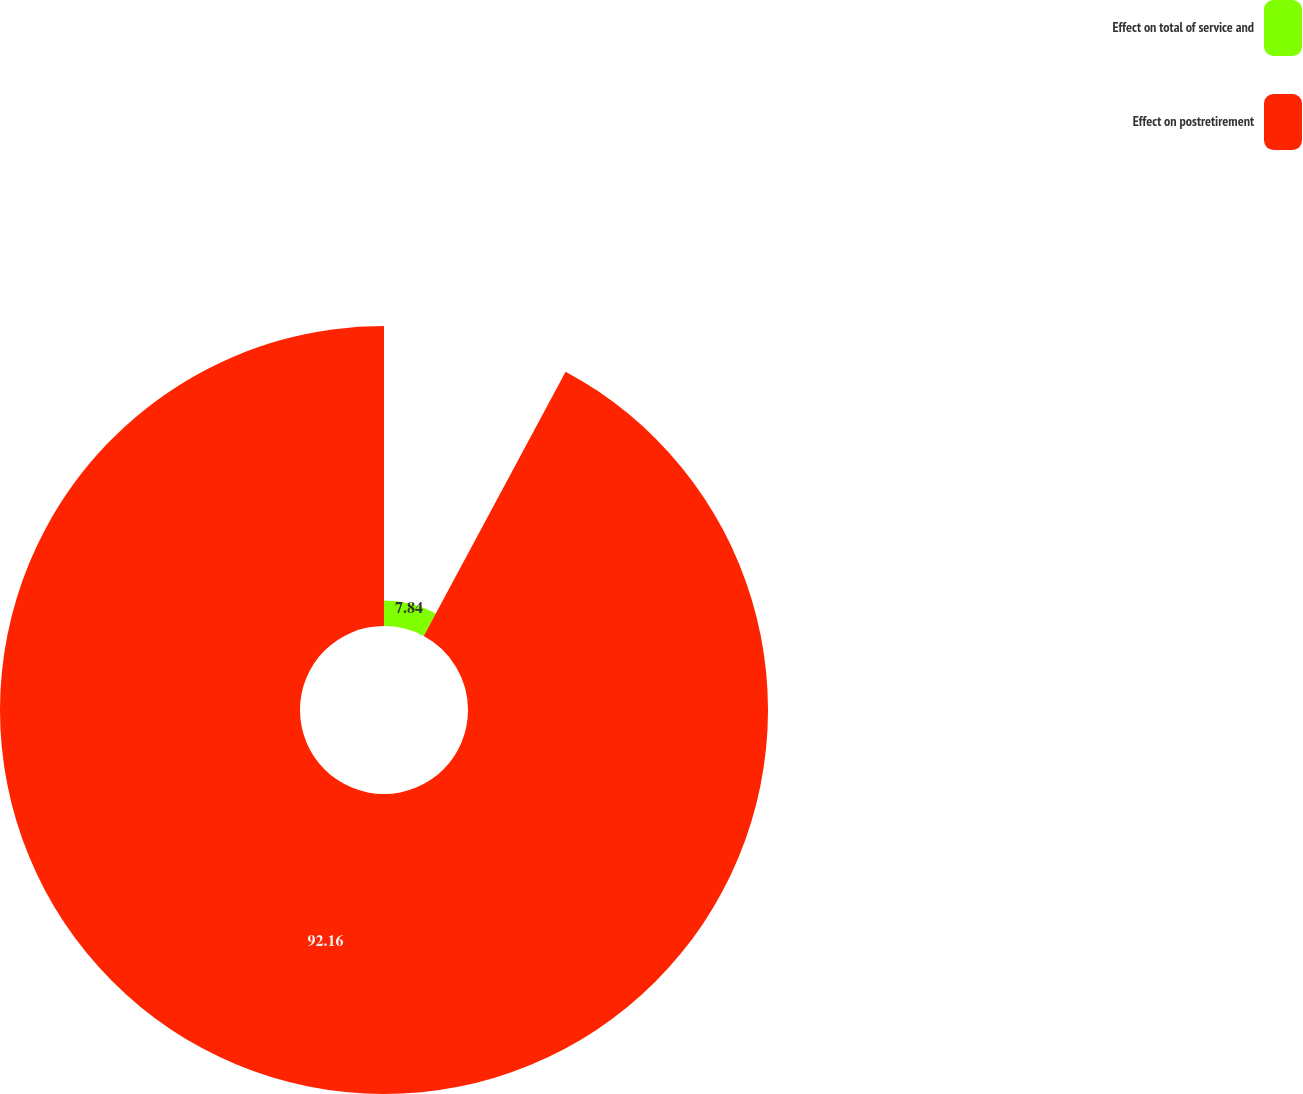Convert chart to OTSL. <chart><loc_0><loc_0><loc_500><loc_500><pie_chart><fcel>Effect on total of service and<fcel>Effect on postretirement<nl><fcel>7.84%<fcel>92.16%<nl></chart> 